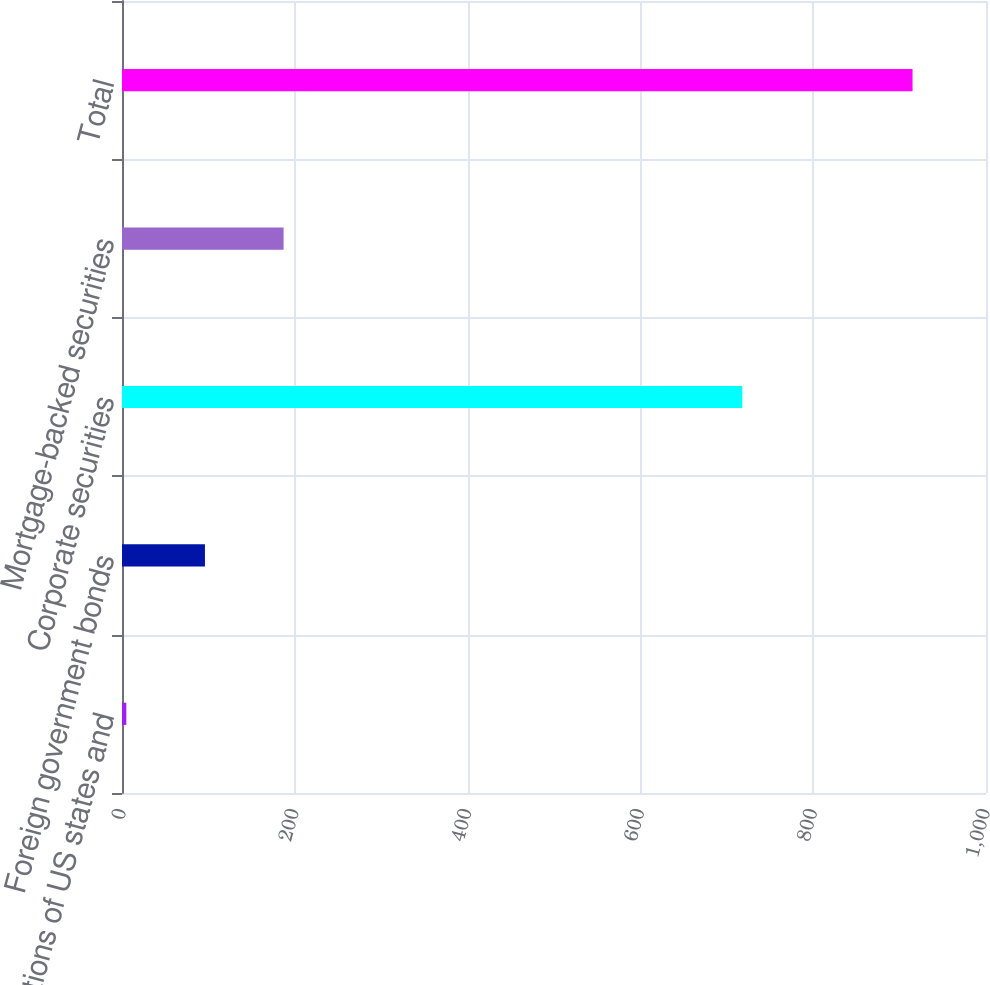Convert chart to OTSL. <chart><loc_0><loc_0><loc_500><loc_500><bar_chart><fcel>Obligations of US states and<fcel>Foreign government bonds<fcel>Corporate securities<fcel>Mortgage-backed securities<fcel>Total<nl><fcel>5<fcel>96<fcel>718<fcel>187<fcel>915<nl></chart> 